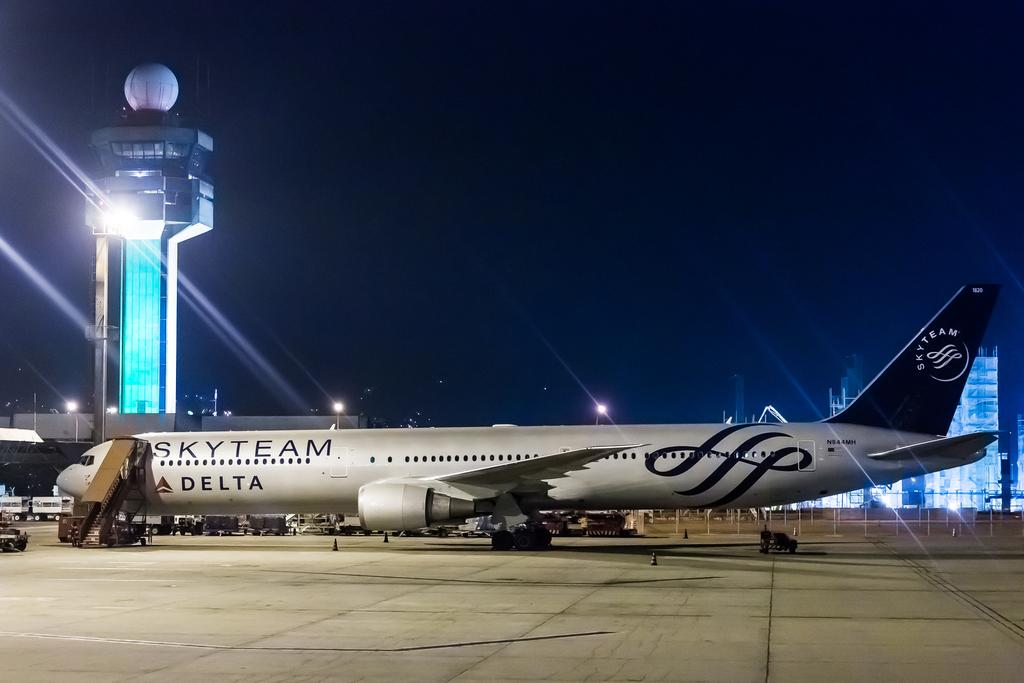<image>
Present a compact description of the photo's key features. A Skyteam plane of Delta's sits on the tarmac at an airport. 